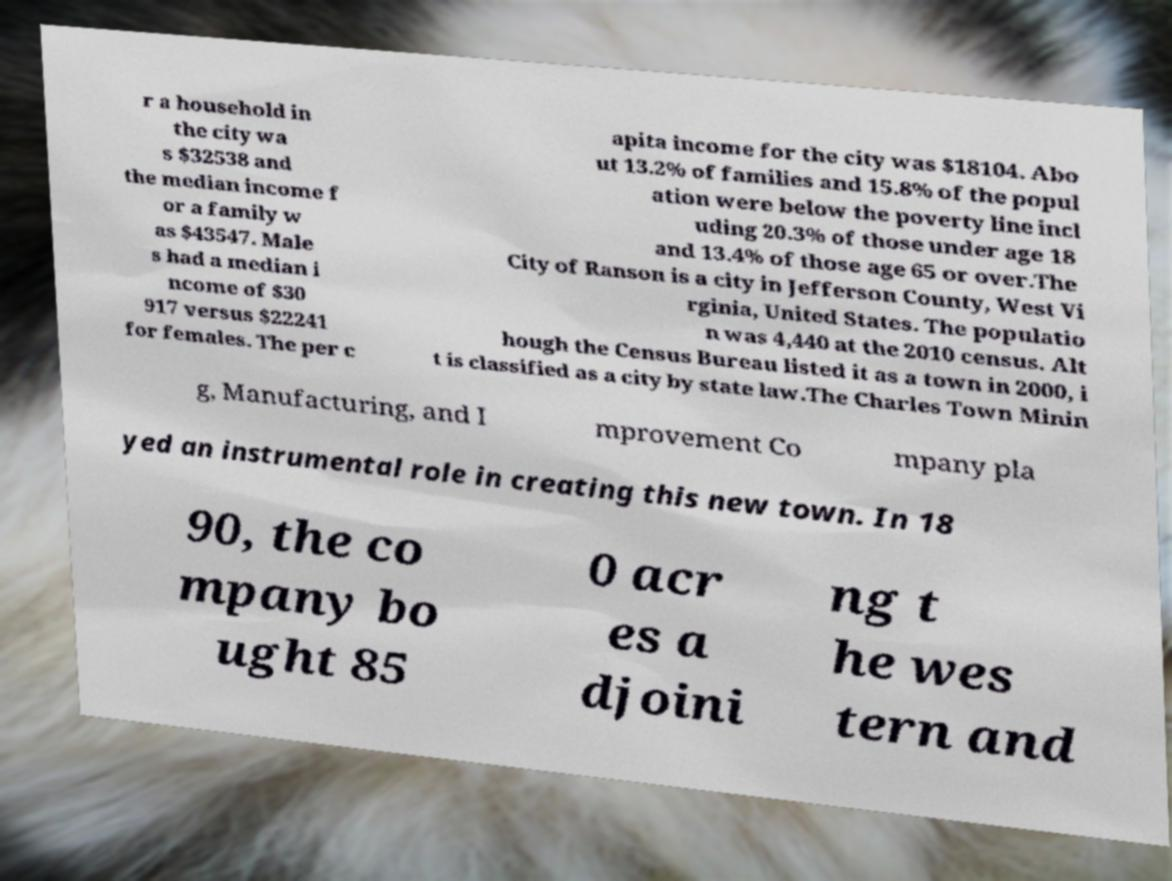Could you assist in decoding the text presented in this image and type it out clearly? r a household in the city wa s $32538 and the median income f or a family w as $43547. Male s had a median i ncome of $30 917 versus $22241 for females. The per c apita income for the city was $18104. Abo ut 13.2% of families and 15.8% of the popul ation were below the poverty line incl uding 20.3% of those under age 18 and 13.4% of those age 65 or over.The City of Ranson is a city in Jefferson County, West Vi rginia, United States. The populatio n was 4,440 at the 2010 census. Alt hough the Census Bureau listed it as a town in 2000, i t is classified as a city by state law.The Charles Town Minin g, Manufacturing, and I mprovement Co mpany pla yed an instrumental role in creating this new town. In 18 90, the co mpany bo ught 85 0 acr es a djoini ng t he wes tern and 